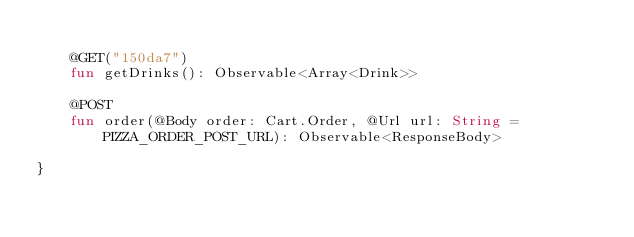Convert code to text. <code><loc_0><loc_0><loc_500><loc_500><_Kotlin_>
    @GET("150da7")
    fun getDrinks(): Observable<Array<Drink>>

    @POST
    fun order(@Body order: Cart.Order, @Url url: String = PIZZA_ORDER_POST_URL): Observable<ResponseBody>

}</code> 